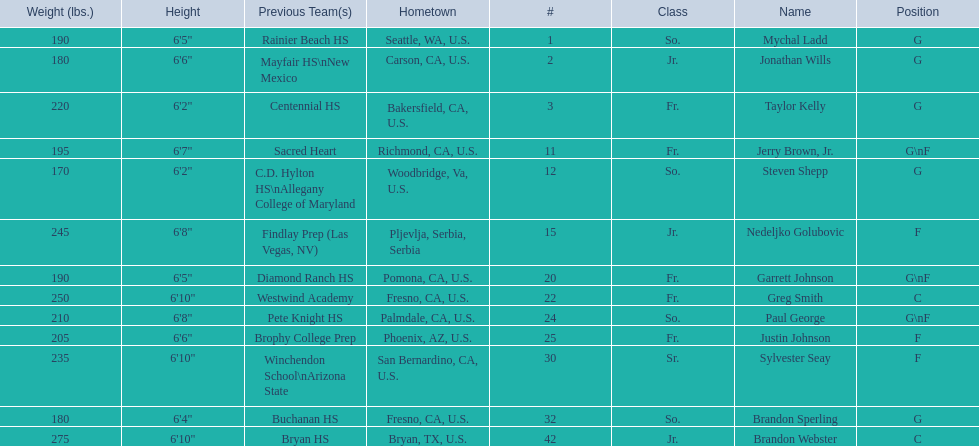Where were all of the players born? So., Jr., Fr., Fr., So., Jr., Fr., Fr., So., Fr., Sr., So., Jr. Who is the one from serbia? Nedeljko Golubovic. 